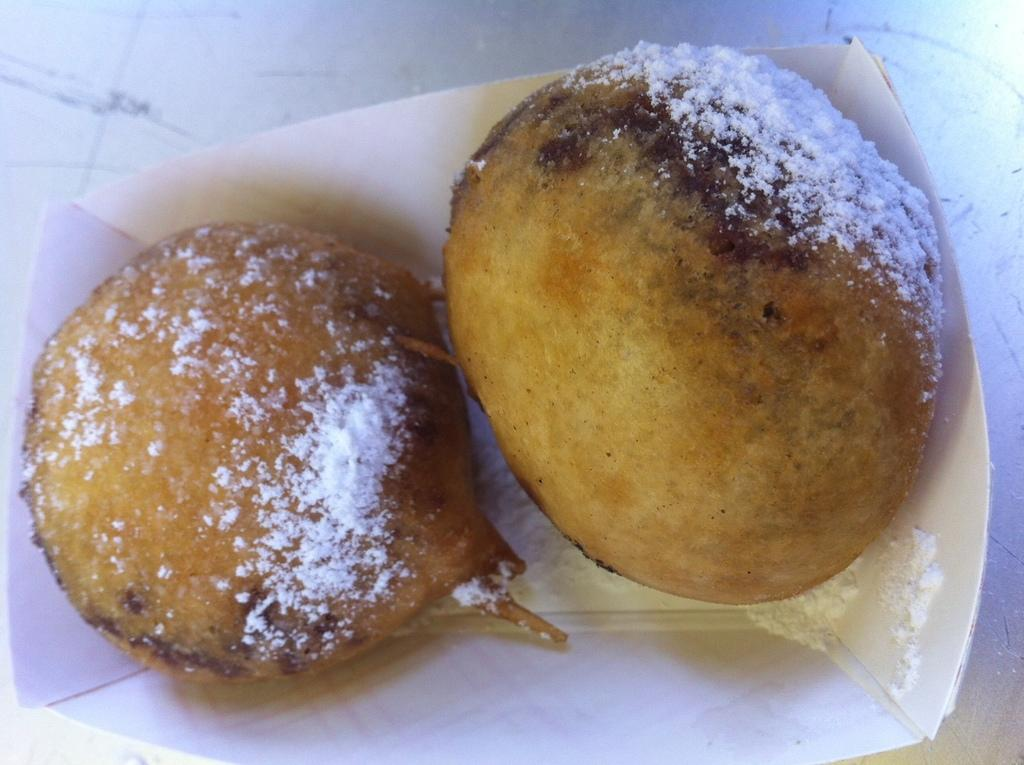What type of container is visible in the image? There is a paper cup in the image. What is inside the paper cup? The paper cup contains food. Can you describe the appearance of the food? The food has white-colored powder on it. What type of arch can be seen in the background of the image? There is no arch present in the image; it only features a paper cup with food and white-colored powder. 